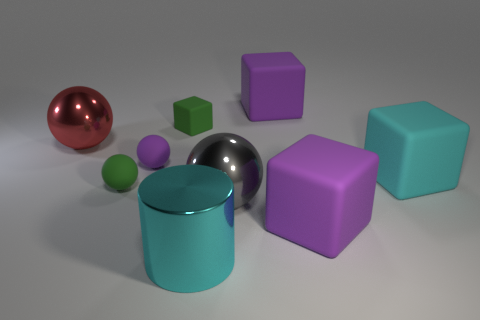What material is the large cyan object that is in front of the small green rubber sphere to the left of the cyan matte thing to the right of the big gray thing?
Provide a succinct answer. Metal. There is a ball behind the small purple rubber ball; is it the same size as the green thing that is behind the green matte sphere?
Your response must be concise. No. What number of other things are made of the same material as the small purple object?
Make the answer very short. 5. What number of matte objects are either big yellow spheres or balls?
Give a very brief answer. 2. Are there fewer large matte things than cyan blocks?
Offer a terse response. No. There is a purple rubber ball; does it have the same size as the purple cube that is in front of the cyan rubber cube?
Keep it short and to the point. No. Are there any other things that have the same shape as the gray object?
Ensure brevity in your answer.  Yes. What size is the gray thing?
Your answer should be very brief. Large. Is the number of tiny matte cubes in front of the green cube less than the number of cyan cubes?
Give a very brief answer. Yes. Do the cyan matte object and the gray shiny thing have the same size?
Offer a terse response. Yes. 